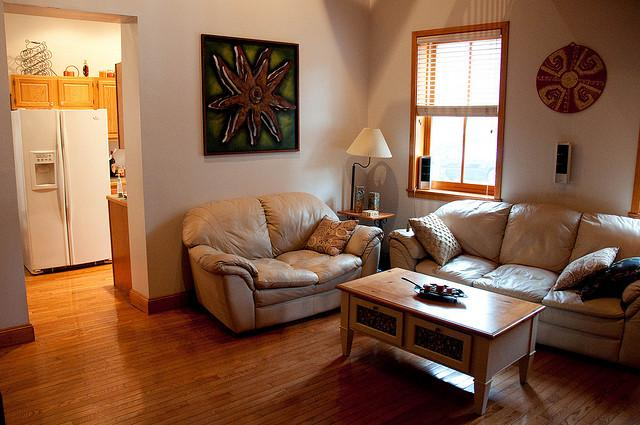What pair of devices are mounted on the wall and in the window sill? Please explain your reasoning. speaker. Speakers take the form of the object on the wall. 